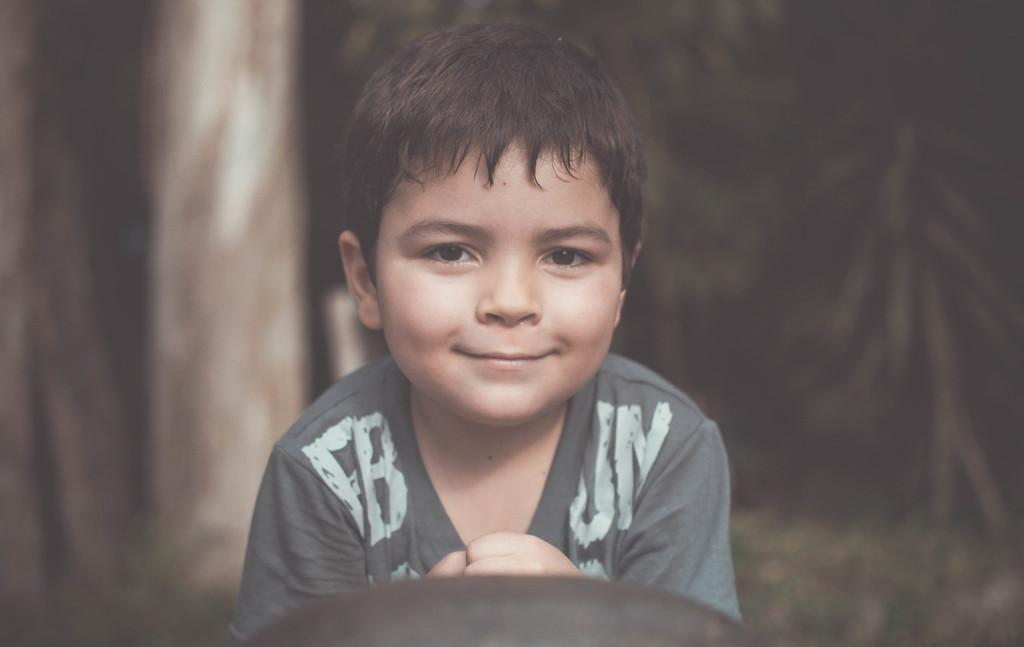What is the main subject of the image? There is a boy in the image. What is the boy wearing? The boy is wearing a grey T-shirt. What is the boy's facial expression? The boy is smiling. How would you describe the background of the image? The background of the image is in black and brown colors, and it is blurred. What type of sail can be seen in the background of the image? There is no sail present in the image; the background is in black and brown colors and is blurred. Is there any exchange of goods happening between the boy and another person in the image? There is no indication of any exchange of goods or interaction with another person in the image, as it only features a boy wearing a grey T-shirt and smiling. 